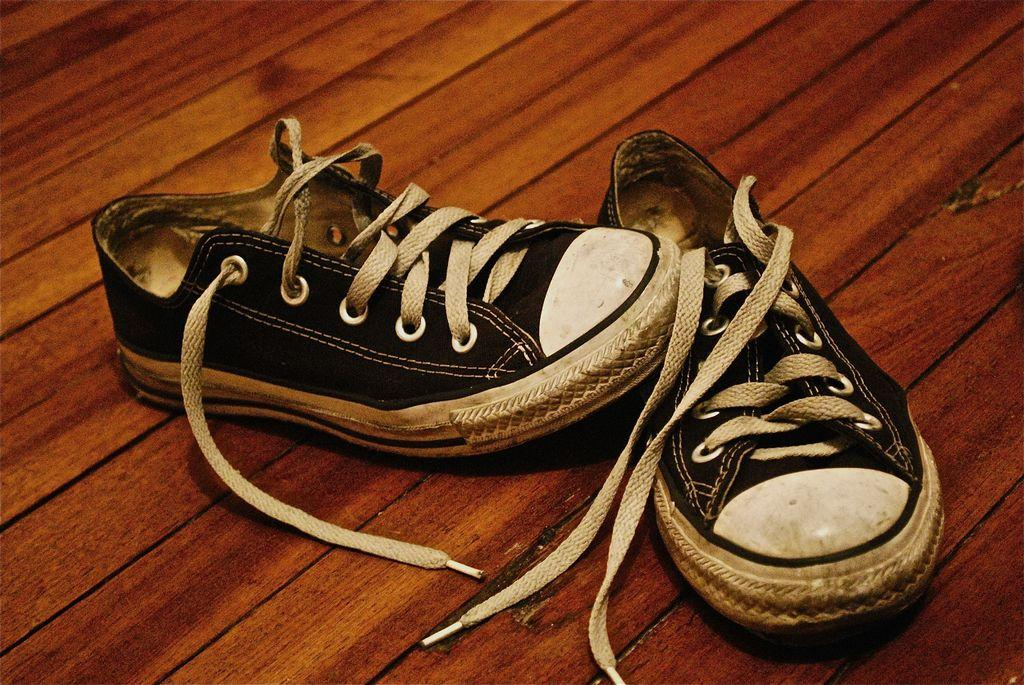What type of shoes are visible in the image? There is a pair of black color shoes in the image. What is the shoes placed on in the image? The shoes are kept on a wooden surface. What type of pie is being served on the cushion in the image? There is no pie or cushion present in the image; it only features a pair of black color shoes on a wooden surface. 